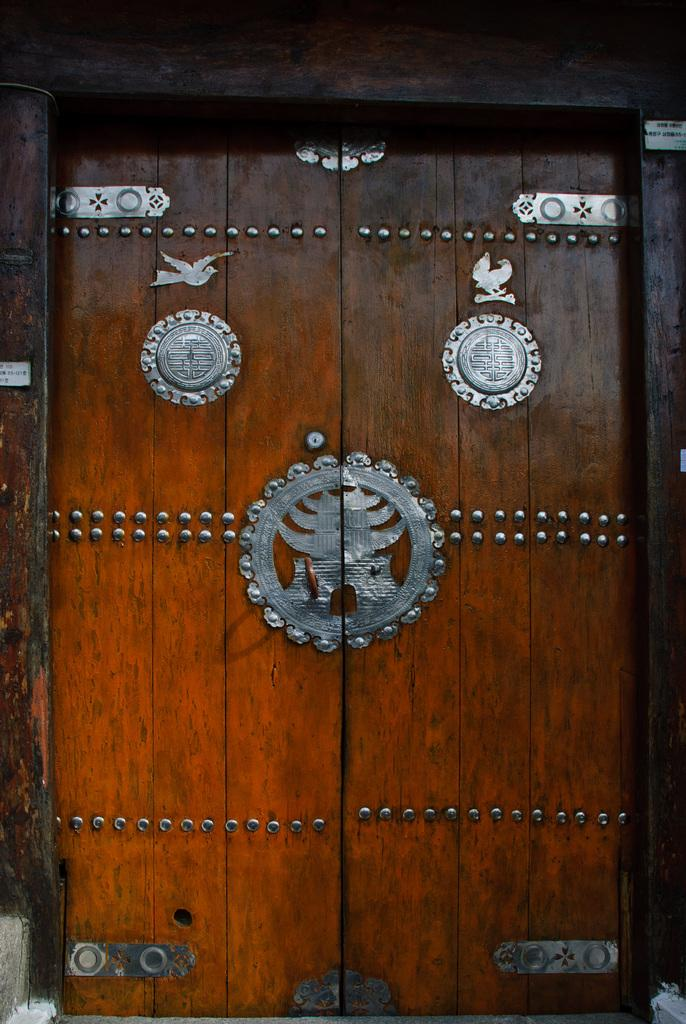What is present in the image that serves as an entry point? There is a door in the image. What material is the door made of? The door is made up of wood. Are there any additional design elements on the door? Yes, there is a metal design on the door. What type of secretary can be seen working behind the door in the image? There is no secretary present in the image; it only features a door made of wood with a metal design. What type of copy is being made in the image? There is no copying activity depicted in the image. 